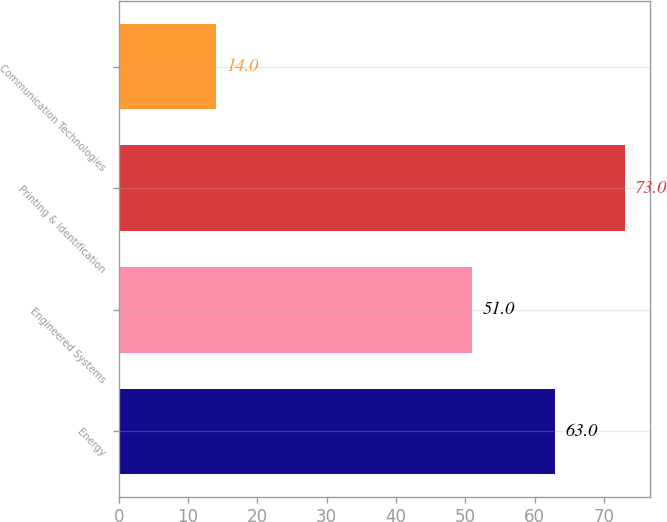Convert chart. <chart><loc_0><loc_0><loc_500><loc_500><bar_chart><fcel>Energy<fcel>Engineered Systems<fcel>Printing & Identification<fcel>Communication Technologies<nl><fcel>63<fcel>51<fcel>73<fcel>14<nl></chart> 